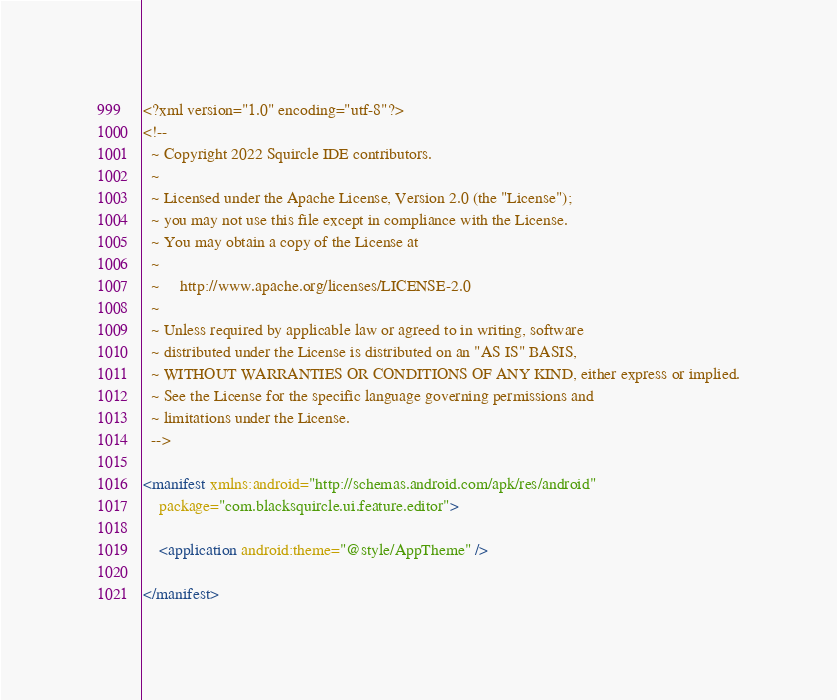Convert code to text. <code><loc_0><loc_0><loc_500><loc_500><_XML_><?xml version="1.0" encoding="utf-8"?>
<!--
  ~ Copyright 2022 Squircle IDE contributors.
  ~
  ~ Licensed under the Apache License, Version 2.0 (the "License");
  ~ you may not use this file except in compliance with the License.
  ~ You may obtain a copy of the License at
  ~
  ~     http://www.apache.org/licenses/LICENSE-2.0
  ~
  ~ Unless required by applicable law or agreed to in writing, software
  ~ distributed under the License is distributed on an "AS IS" BASIS,
  ~ WITHOUT WARRANTIES OR CONDITIONS OF ANY KIND, either express or implied.
  ~ See the License for the specific language governing permissions and
  ~ limitations under the License.
  -->

<manifest xmlns:android="http://schemas.android.com/apk/res/android"
    package="com.blacksquircle.ui.feature.editor">

    <application android:theme="@style/AppTheme" />

</manifest></code> 